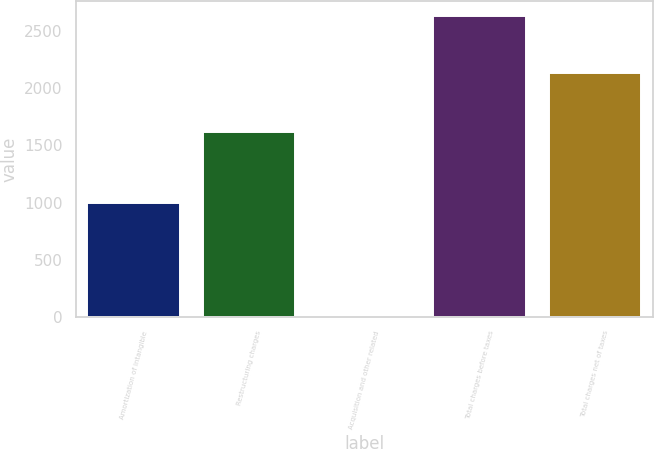Convert chart. <chart><loc_0><loc_0><loc_500><loc_500><bar_chart><fcel>Amortization of intangible<fcel>Restructuring charges<fcel>Acquisition and other related<fcel>Total charges before taxes<fcel>Total charges net of taxes<nl><fcel>1000<fcel>1619<fcel>11<fcel>2630<fcel>2132<nl></chart> 